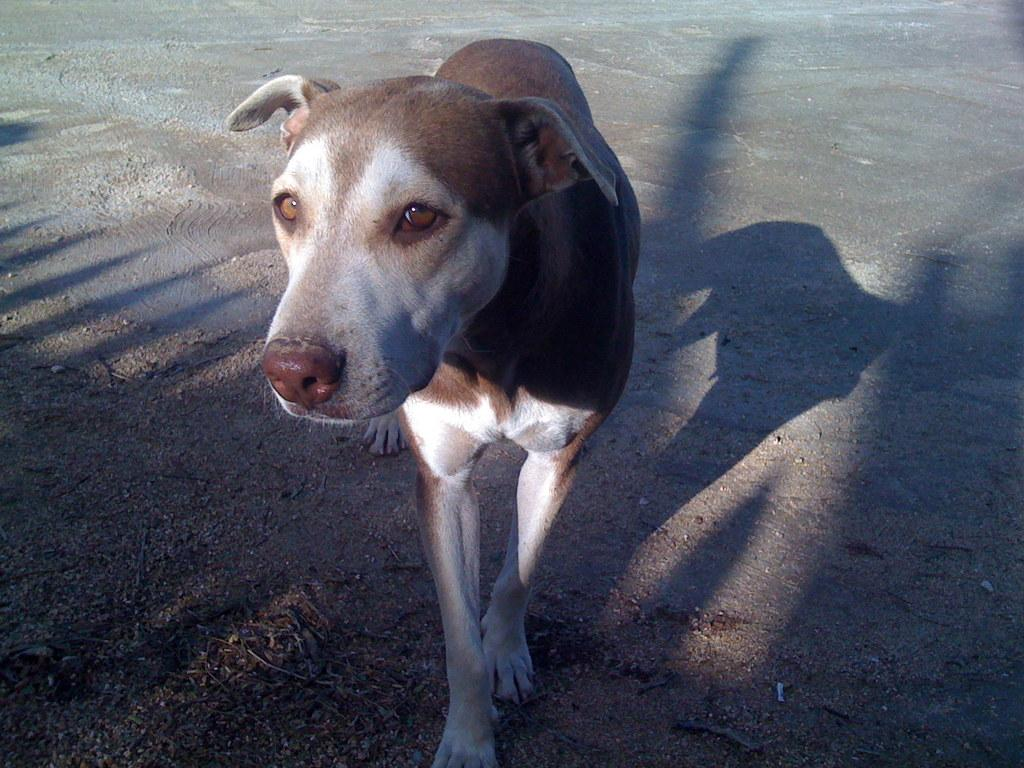What type of animal is in the image? There is a dog in the image. Can you describe the dog's appearance? The dog has a brown and white color. What is the dog doing in the image? The dog is standing. What can be seen on the ground in the image? There are shadows visible on the ground in the image. What type of boot is the dog wearing in the image? There is no boot present in the image; the dog is not wearing any footwear. 